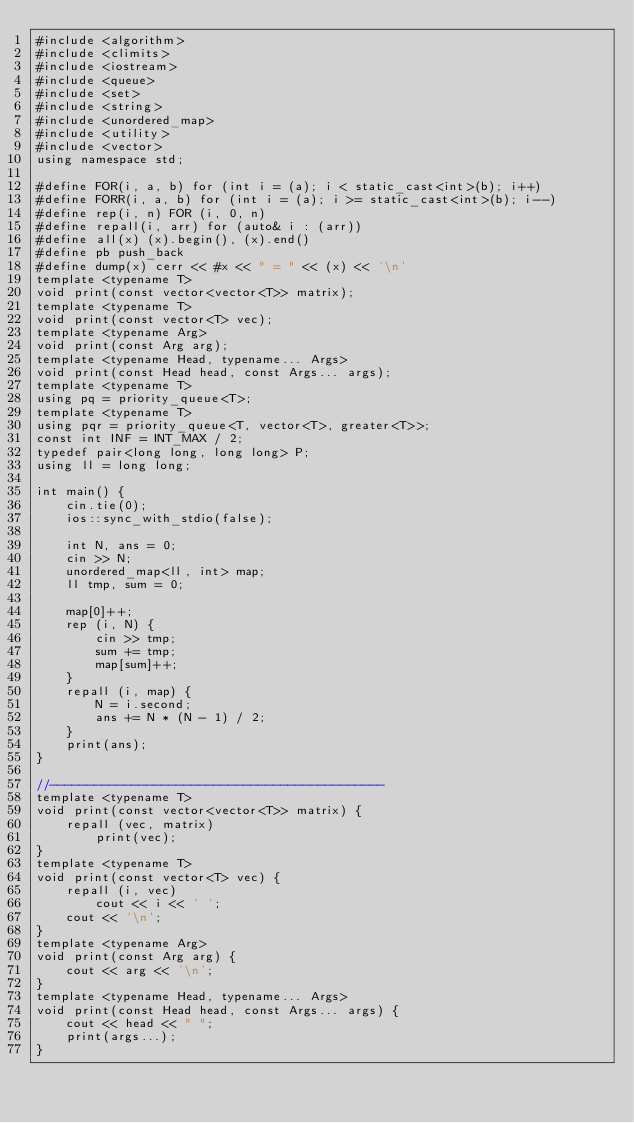<code> <loc_0><loc_0><loc_500><loc_500><_C++_>#include <algorithm>
#include <climits>
#include <iostream>
#include <queue>
#include <set>
#include <string>
#include <unordered_map>
#include <utility>
#include <vector>
using namespace std;

#define FOR(i, a, b) for (int i = (a); i < static_cast<int>(b); i++)
#define FORR(i, a, b) for (int i = (a); i >= static_cast<int>(b); i--)
#define rep(i, n) FOR (i, 0, n)
#define repall(i, arr) for (auto& i : (arr))
#define all(x) (x).begin(), (x).end()
#define pb push_back
#define dump(x) cerr << #x << " = " << (x) << '\n'
template <typename T>
void print(const vector<vector<T>> matrix);
template <typename T>
void print(const vector<T> vec);
template <typename Arg>
void print(const Arg arg);
template <typename Head, typename... Args>
void print(const Head head, const Args... args);
template <typename T>
using pq = priority_queue<T>;
template <typename T>
using pqr = priority_queue<T, vector<T>, greater<T>>;
const int INF = INT_MAX / 2;
typedef pair<long long, long long> P;
using ll = long long;

int main() {
    cin.tie(0);
    ios::sync_with_stdio(false);

    int N, ans = 0;
    cin >> N;
    unordered_map<ll, int> map;
    ll tmp, sum = 0;

    map[0]++;
    rep (i, N) {
        cin >> tmp;
        sum += tmp;
        map[sum]++;
    }
    repall (i, map) {
        N = i.second;
        ans += N * (N - 1) / 2;
    }
    print(ans);
}

//---------------------------------------------
template <typename T>
void print(const vector<vector<T>> matrix) {
    repall (vec, matrix)
        print(vec);
}
template <typename T>
void print(const vector<T> vec) {
    repall (i, vec)
        cout << i << ' ';
    cout << '\n';
}
template <typename Arg>
void print(const Arg arg) {
    cout << arg << '\n';
}
template <typename Head, typename... Args>
void print(const Head head, const Args... args) {
    cout << head << " ";
    print(args...);
}
</code> 